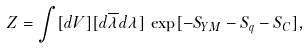<formula> <loc_0><loc_0><loc_500><loc_500>Z = \int [ d V ] [ d \overline { \lambda } d \lambda ] \, \exp [ - S _ { Y M } - S _ { q } - S _ { C } ] ,</formula> 